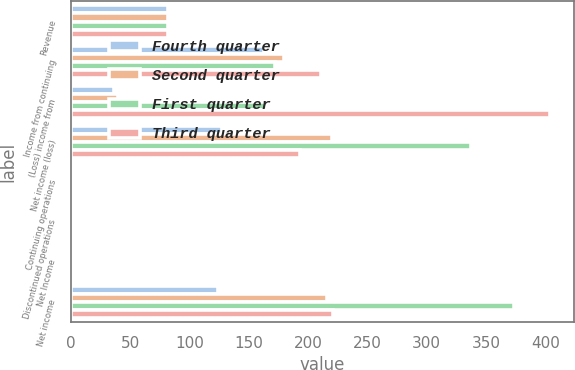<chart> <loc_0><loc_0><loc_500><loc_500><stacked_bar_chart><ecel><fcel>Revenue<fcel>Income from continuing<fcel>(Loss) income from<fcel>Net income (loss)<fcel>Continuing operations<fcel>Discontinued operations<fcel>Net Income<fcel>Net income<nl><fcel>Fourth quarter<fcel>82<fcel>163<fcel>36<fcel>127<fcel>0.57<fcel>0.13<fcel>0.44<fcel>124<nl><fcel>Second quarter<fcel>82<fcel>180<fcel>40<fcel>220<fcel>0.63<fcel>0.14<fcel>0.77<fcel>216<nl><fcel>First quarter<fcel>82<fcel>172<fcel>165<fcel>337<fcel>0.54<fcel>0.58<fcel>1.13<fcel>374<nl><fcel>Third quarter<fcel>82<fcel>211<fcel>404<fcel>193<fcel>0.68<fcel>1.46<fcel>0.78<fcel>221<nl></chart> 